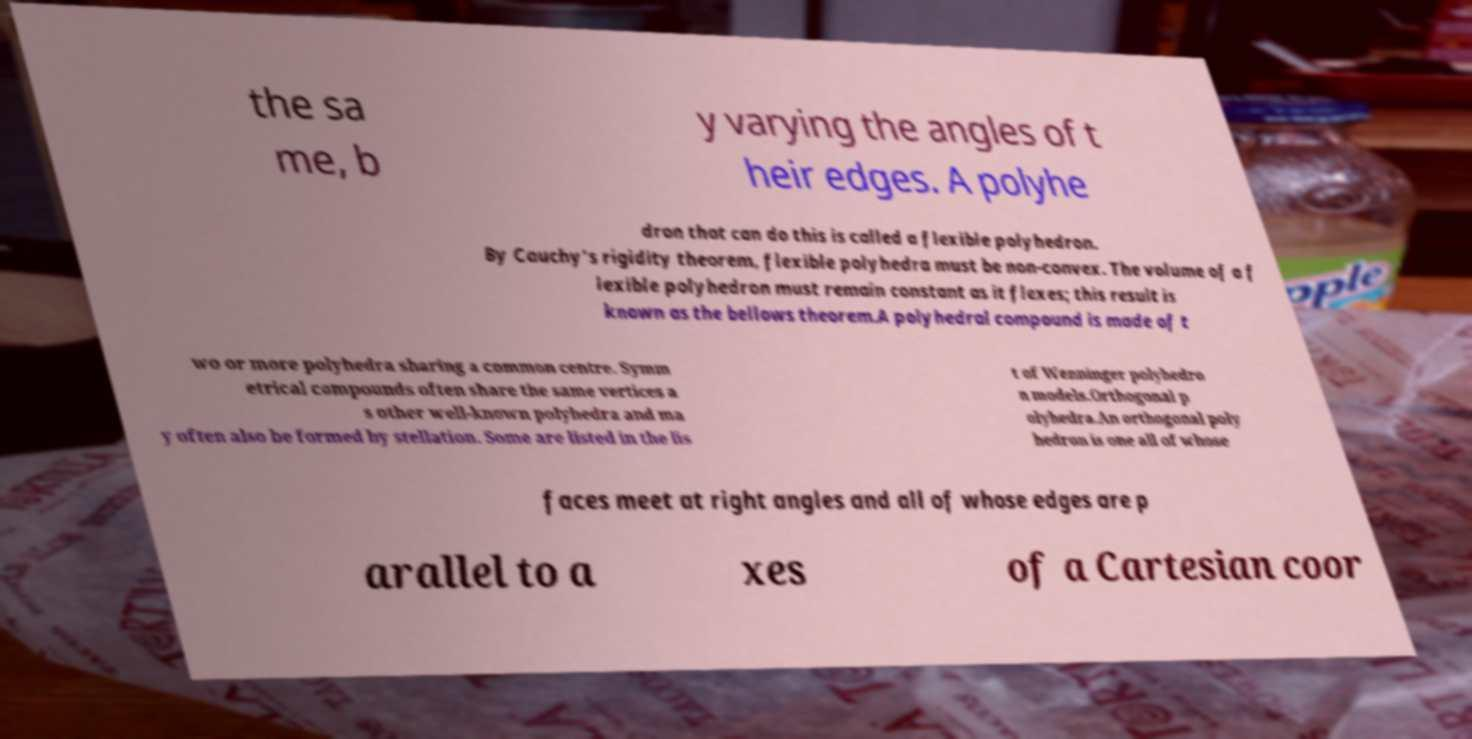There's text embedded in this image that I need extracted. Can you transcribe it verbatim? the sa me, b y varying the angles of t heir edges. A polyhe dron that can do this is called a flexible polyhedron. By Cauchy's rigidity theorem, flexible polyhedra must be non-convex. The volume of a f lexible polyhedron must remain constant as it flexes; this result is known as the bellows theorem.A polyhedral compound is made of t wo or more polyhedra sharing a common centre. Symm etrical compounds often share the same vertices a s other well-known polyhedra and ma y often also be formed by stellation. Some are listed in the lis t of Wenninger polyhedro n models.Orthogonal p olyhedra.An orthogonal poly hedron is one all of whose faces meet at right angles and all of whose edges are p arallel to a xes of a Cartesian coor 